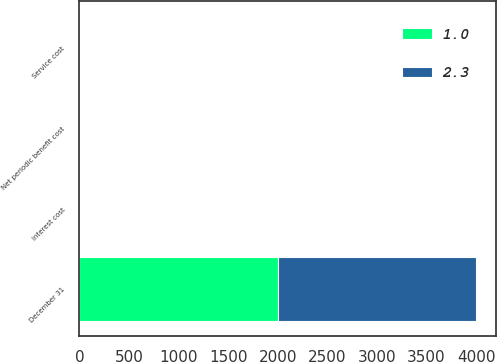Convert chart. <chart><loc_0><loc_0><loc_500><loc_500><stacked_bar_chart><ecel><fcel>December 31<fcel>Service cost<fcel>Interest cost<fcel>Net periodic benefit cost<nl><fcel>2.3<fcel>2002<fcel>1.1<fcel>1.2<fcel>2.3<nl><fcel>1<fcel>2001<fcel>0.5<fcel>0.5<fcel>1<nl></chart> 